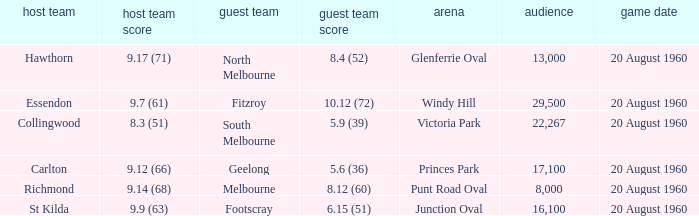What is the crowd size of the game when Fitzroy is the away team? 1.0. 